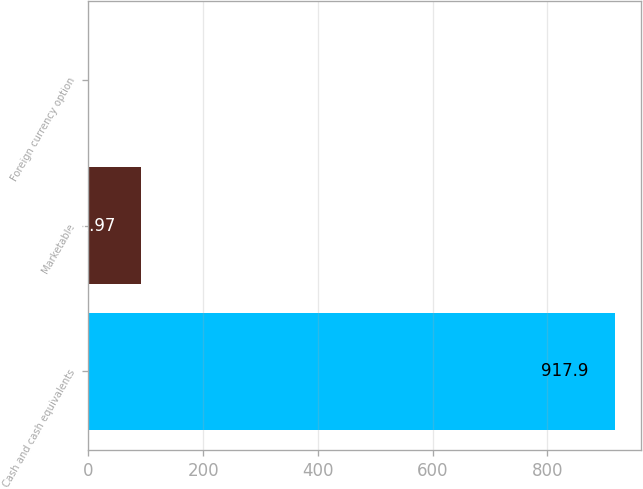<chart> <loc_0><loc_0><loc_500><loc_500><bar_chart><fcel>Cash and cash equivalents<fcel>Marketable<fcel>Foreign currency option<nl><fcel>917.9<fcel>91.97<fcel>0.2<nl></chart> 